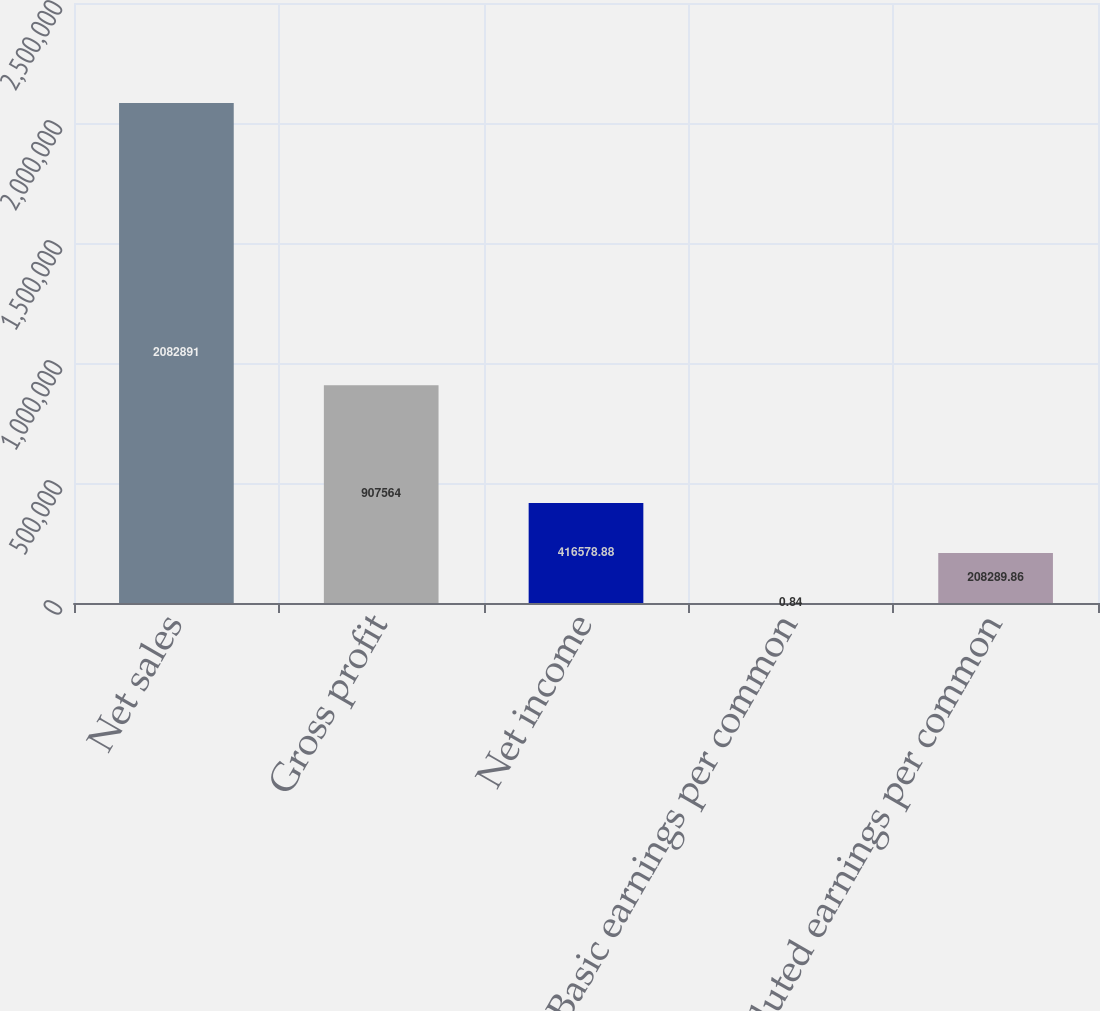Convert chart. <chart><loc_0><loc_0><loc_500><loc_500><bar_chart><fcel>Net sales<fcel>Gross profit<fcel>Net income<fcel>Basic earnings per common<fcel>Diluted earnings per common<nl><fcel>2.08289e+06<fcel>907564<fcel>416579<fcel>0.84<fcel>208290<nl></chart> 